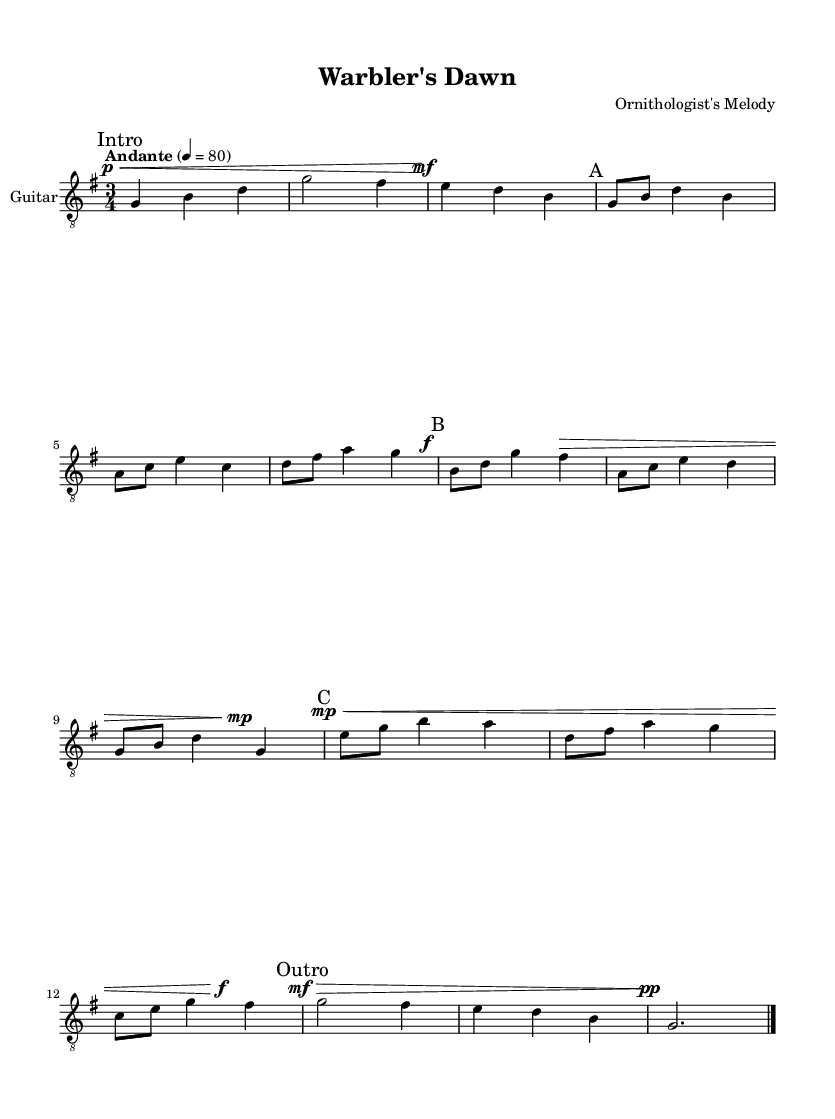What is the key signature of this music? The key signature is G major, as indicated by one sharp (F#) shown at the beginning of the staff.
Answer: G major What is the time signature of this music? The time signature is written as 3/4, which shows that there are three beats per measure and the quarter note gets the beat.
Answer: 3/4 What is the tempo marking for this piece? The tempo marking indicates "Andante" with a metronome marking of 80 beats per minute, which suggests a moderately slow pace.
Answer: Andante How many sections does this piece have? The piece is divided into four distinct sections labeled as Intro, A, B, C, and an Outro, making a total of five sections.
Answer: Five In Section B, what is the first note played? The first note in Section B is B, which is indicated as the first note of the phrase in that section.
Answer: B Which dynamic marking appears in Section C? The dynamic marking in Section C is marked as "mp," which stands for "mezzo-piano," indicating a moderately soft volume level.
Answer: mp What is the final measure's type at the end of the music? The final measure is marked with a double bar line and a fermata, indicating the piece’s conclusion and a pause at the end.
Answer: Fermata 